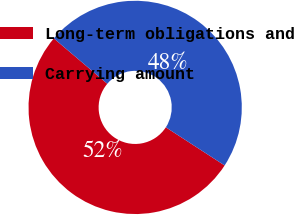<chart> <loc_0><loc_0><loc_500><loc_500><pie_chart><fcel>Long-term obligations and<fcel>Carrying amount<nl><fcel>52.04%<fcel>47.96%<nl></chart> 